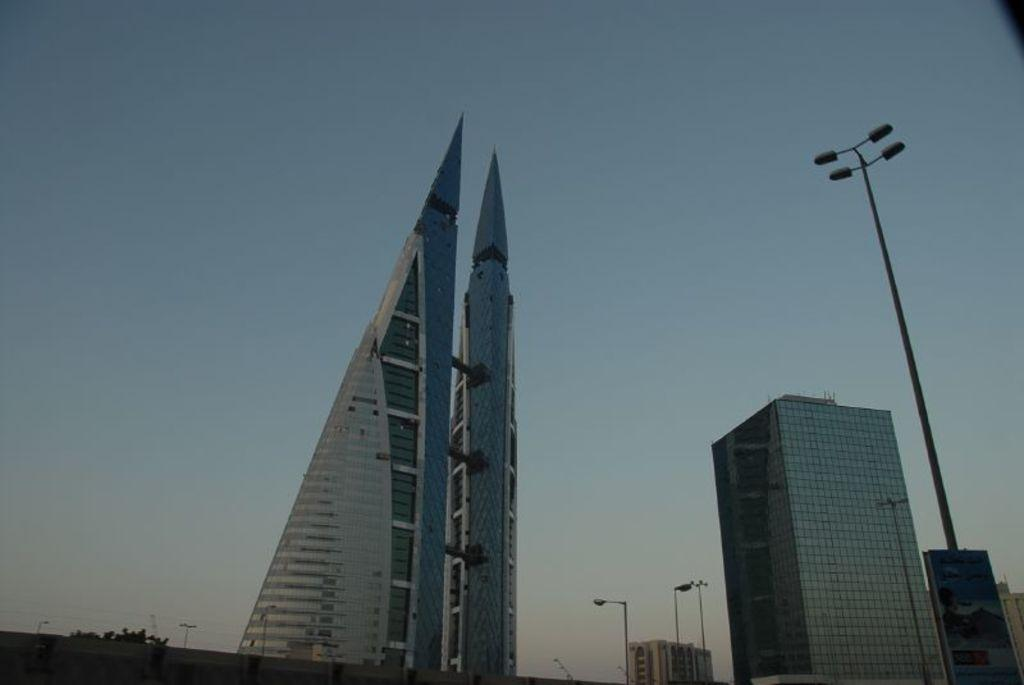What type of structures can be seen in the image? There are buildings in the image. What else can be seen in the image besides the buildings? There are light poles in the image. What part of the natural environment is visible in the image? The sky is visible in the image. What type of advertisement can be seen on the buildings in the image? There is no advertisement present on the buildings in the image. What property of the light poles causes them to spark in the image? There is no indication of sparks or any electrical issues with the light poles in the image. 